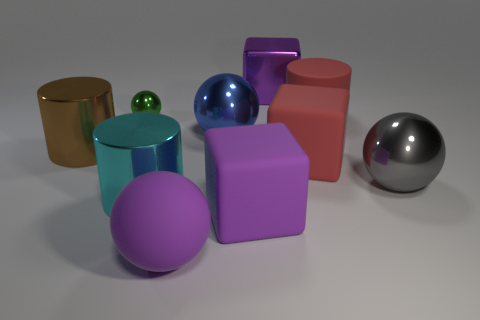What kind of lighting is used in this scene? The lighting in this scene appears to be soft and diffused, as indicated by the gentle shadows under the objects and the subtle highlights on their surfaces. There are no harsh shadows or bright hotspots, suggesting that the light source is neither too direct nor too intense. 